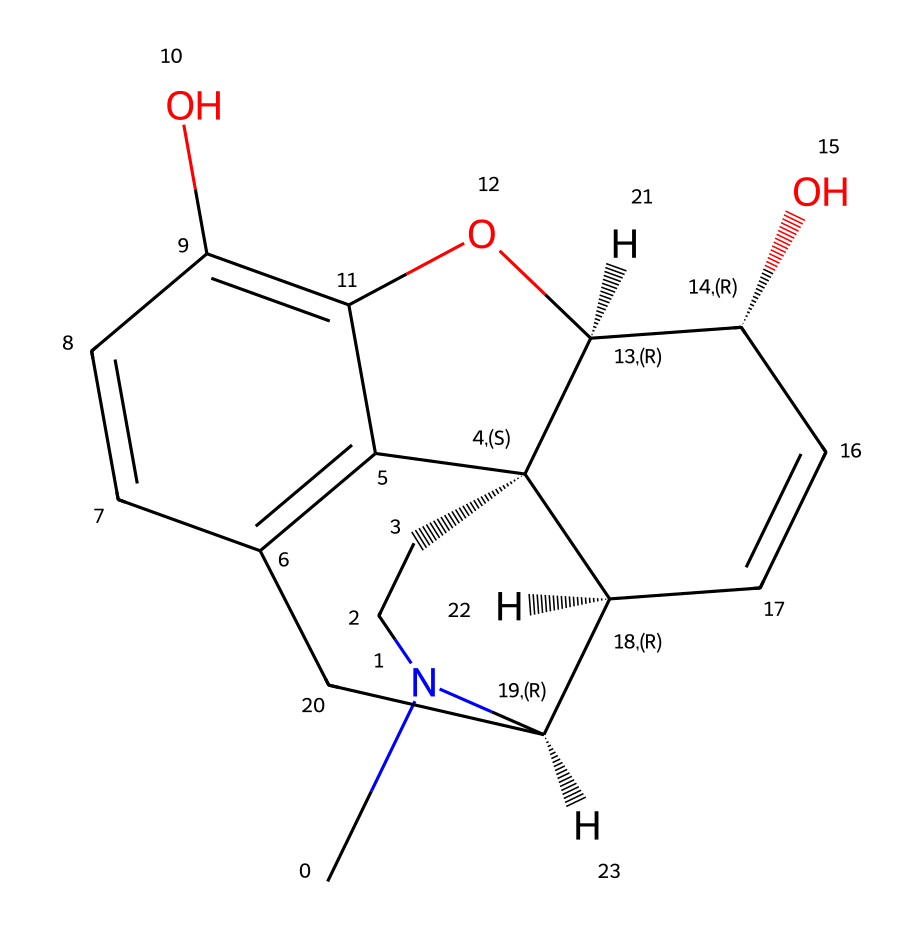What is the molecular formula of morphine? Analyzing the chemical structure, we can count the number of each type of atom present. The chemical has 17 carbon (C) atoms, 19 hydrogen (H) atoms, 1 nitrogen (N) atom, and 3 oxygen (O) atoms, leading to the molecular formula C17H19N3O3.
Answer: C17H19N3O3 How many rings are present in the morphine structure? By examining the structure, we can identify several interconnected cyclic structures. In morphine, there are five interconnected rings in total.
Answer: 5 What functional groups are present in morphine? Looking at the chemical structure, we can identify specific arrangements of atoms that characterize functional groups. Morphine contains hydroxyl (–OH) groups and an ether (–O–) linkage.
Answer: hydroxyl and ether What is the significance of the nitrogen atom in morphine? In alkaloids, the nitrogen atom is crucial for biological activity. In morphine, the nitrogen contributes to its basicity and interaction with opioid receptors, affecting its pharmacological properties.
Answer: basicity and receptor interaction What is the stereochemistry of morphine? Analyzing the structure reveals multiple chiral centers indicated by their specific connectivity. Morphine contains several stereocenters that contribute to its activity, resulting in a specific three-dimensional orientation.
Answer: several stereocenters In how many positions does morphine have hydroxyl groups? By closely examining the structure, we can identify the positions where hydroxyl groups are attached. Morphine has two hydroxyl groups at the 3 and 6 positions on the aromatic ring system.
Answer: 2 